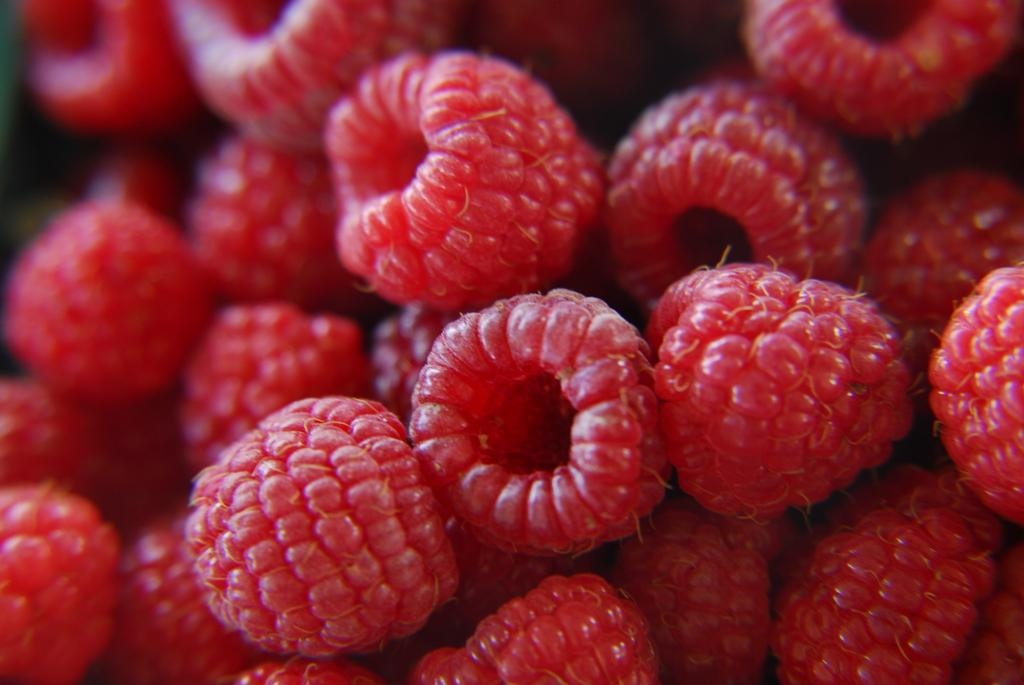What type of fruit is present in the image? There are raspberries in the image. What is the title of the song being sung by the raspberries in the image? There is no song being sung by the raspberries in the image, as raspberries are fruit and do not have the ability to sing. 